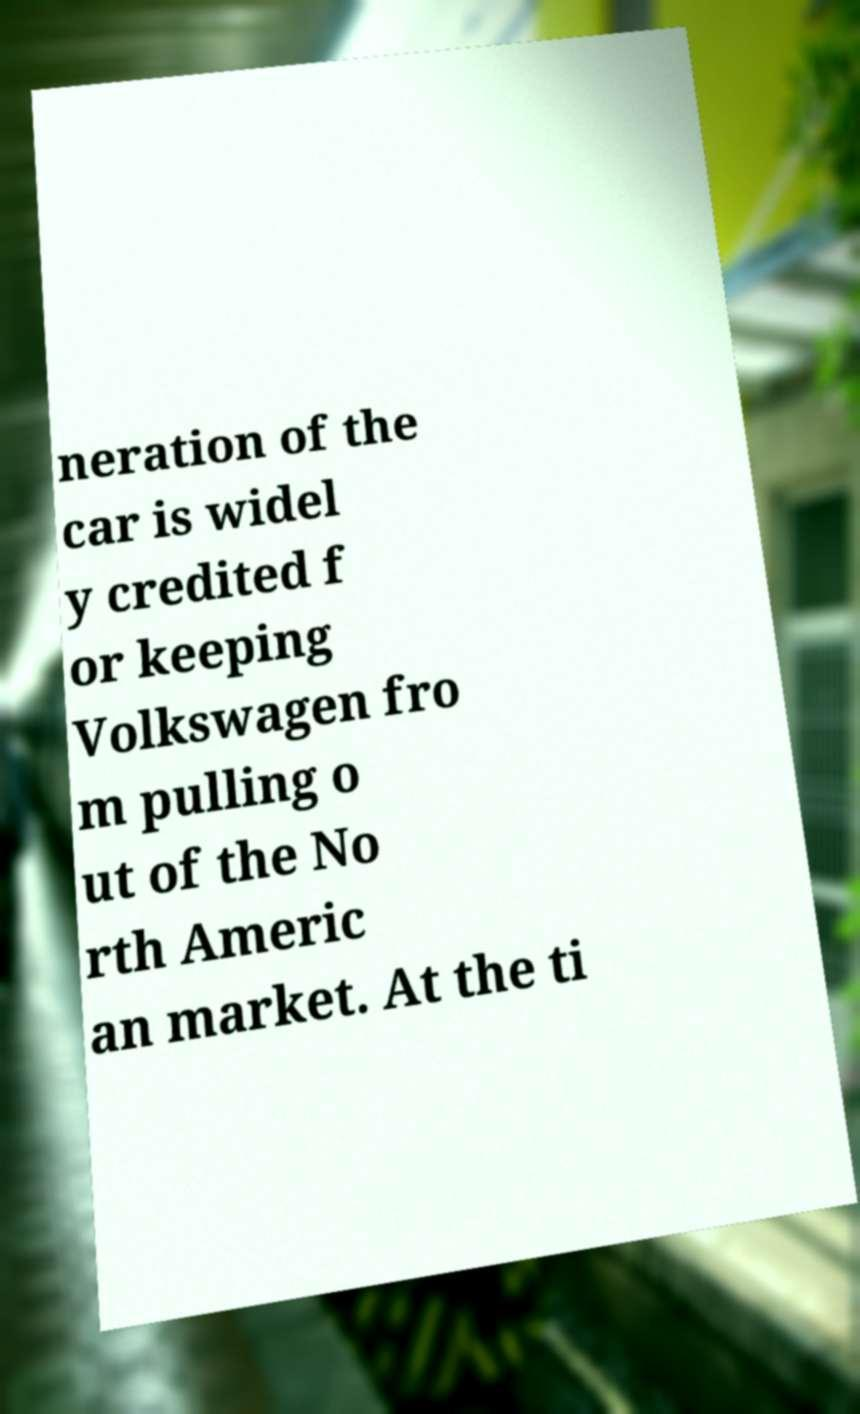I need the written content from this picture converted into text. Can you do that? neration of the car is widel y credited f or keeping Volkswagen fro m pulling o ut of the No rth Americ an market. At the ti 